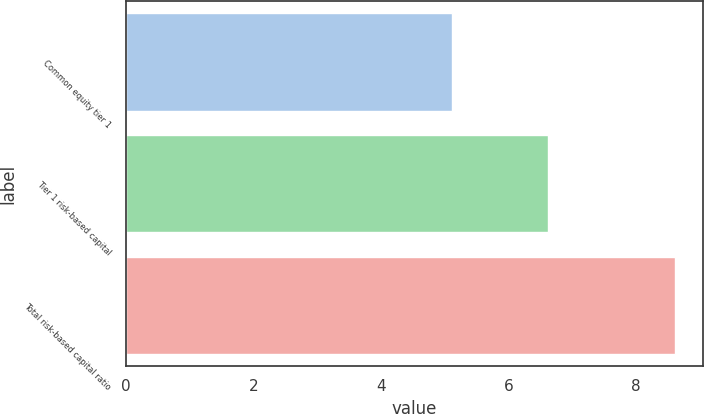Convert chart. <chart><loc_0><loc_0><loc_500><loc_500><bar_chart><fcel>Common equity tier 1<fcel>Tier 1 risk-based capital<fcel>Total risk-based capital ratio<nl><fcel>5.12<fcel>6.62<fcel>8.62<nl></chart> 